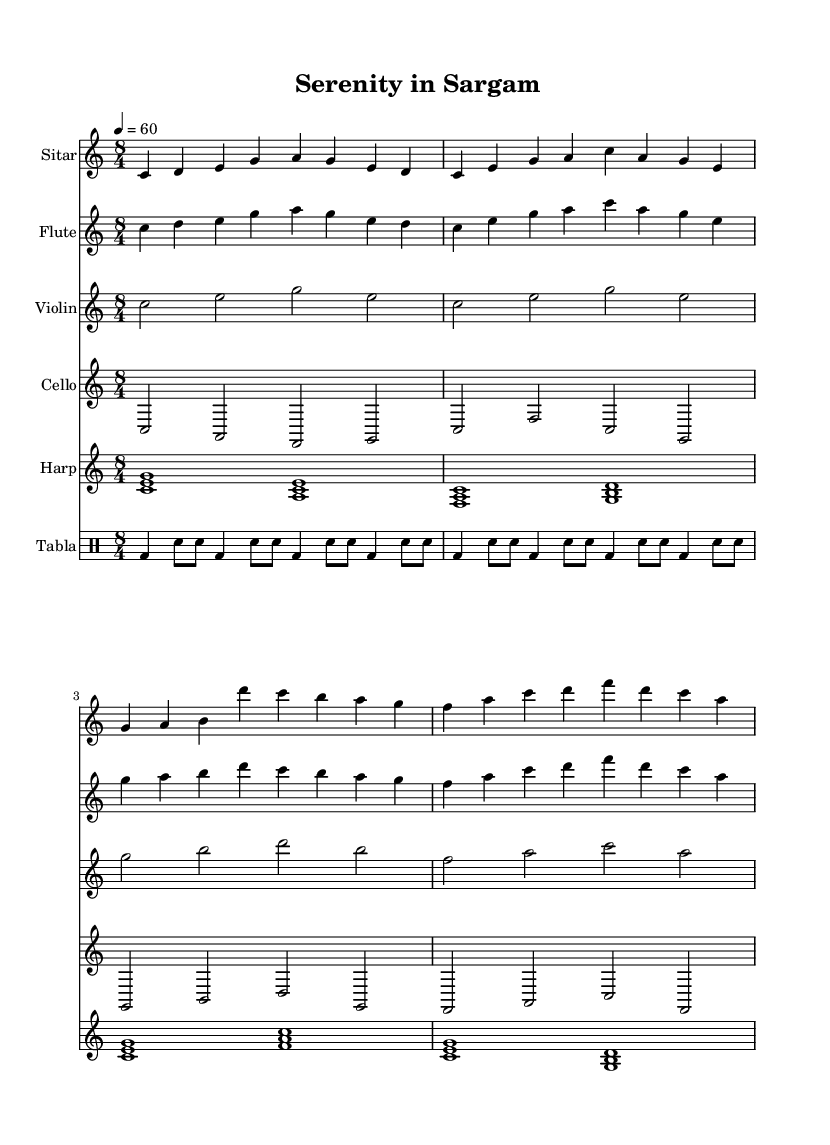What is the key signature of this music? The key signature is C major, which can be identified by the absence of sharps or flats present on the staff.
Answer: C major What is the time signature of this piece? The time signature, indicated at the beginning of the music, is 8/4. This means there are eight beats in each measure, with the quarter note getting one beat.
Answer: 8/4 What is the tempo marking for this composition? The tempo marking indicates a speed of quarter note equals 60 beats per minute, which provides a slow and relaxing pace for the piece.
Answer: 60 How many instruments are represented in the score? By counting each staff notated in the score, we find a total of six instruments: Sitar, Flute, Violin, Cello, Harp, and Tabla.
Answer: Six Which instrument has the slowest note values? Looking at the notation, the Violin and Cello parts contain half notes primarily, indicating they have the slowest note values in comparison to the others.
Answer: Violin and Cello What is the rhythmic pattern used in the Tabla section? The rhythmic pattern is denoted by alternating bass and snare sounds, indicated by bd for bass drum and sn for snare, creating a recurring 4/4 rhythm.
Answer: Alternating bass and snare What musical elements are combined in this fusion piece? The piece combines elements of Hindustani classical music, evident in the Sitar and Tabla parts, with Western classical orchestration, represented by the Flute, Violin, Cello, and Harp.
Answer: Hindustani classical and Western classical 